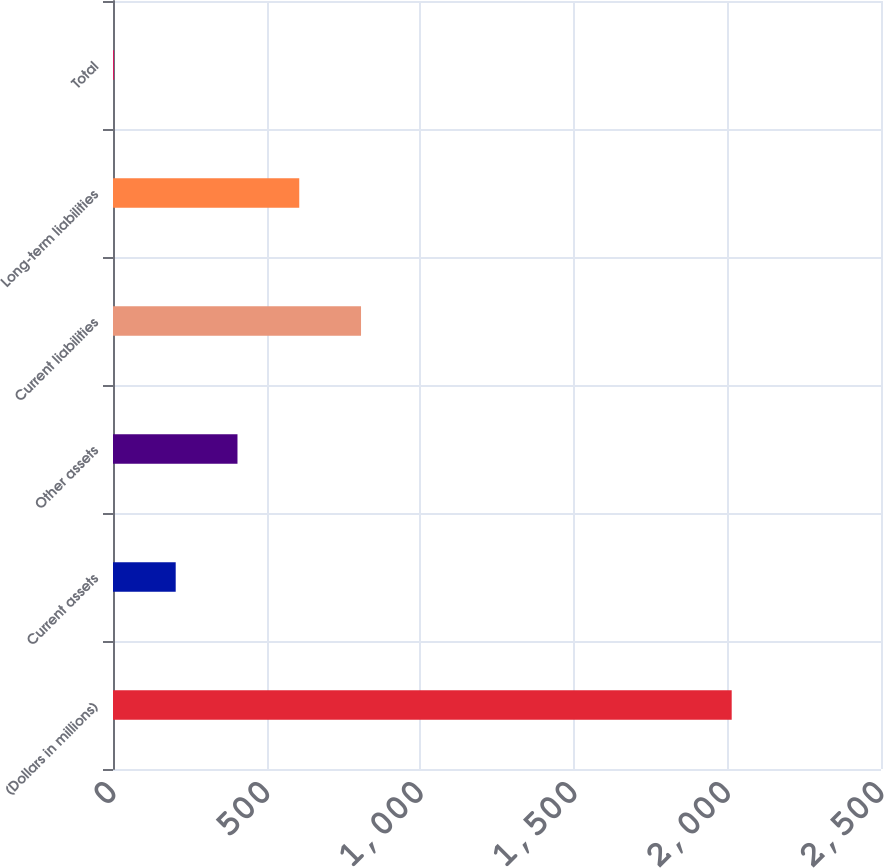<chart> <loc_0><loc_0><loc_500><loc_500><bar_chart><fcel>(Dollars in millions)<fcel>Current assets<fcel>Other assets<fcel>Current liabilities<fcel>Long-term liabilities<fcel>Total<nl><fcel>2014<fcel>204.1<fcel>405.2<fcel>807.4<fcel>606.3<fcel>3<nl></chart> 